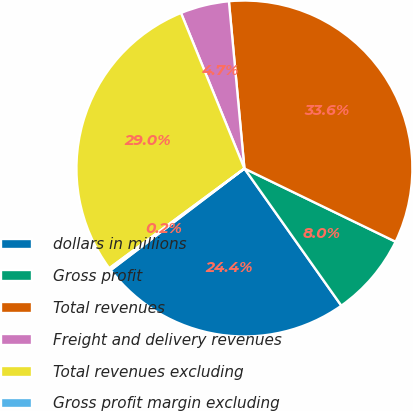Convert chart to OTSL. <chart><loc_0><loc_0><loc_500><loc_500><pie_chart><fcel>dollars in millions<fcel>Gross profit<fcel>Total revenues<fcel>Freight and delivery revenues<fcel>Total revenues excluding<fcel>Gross profit margin excluding<nl><fcel>24.45%<fcel>8.03%<fcel>33.65%<fcel>4.69%<fcel>28.96%<fcel>0.22%<nl></chart> 